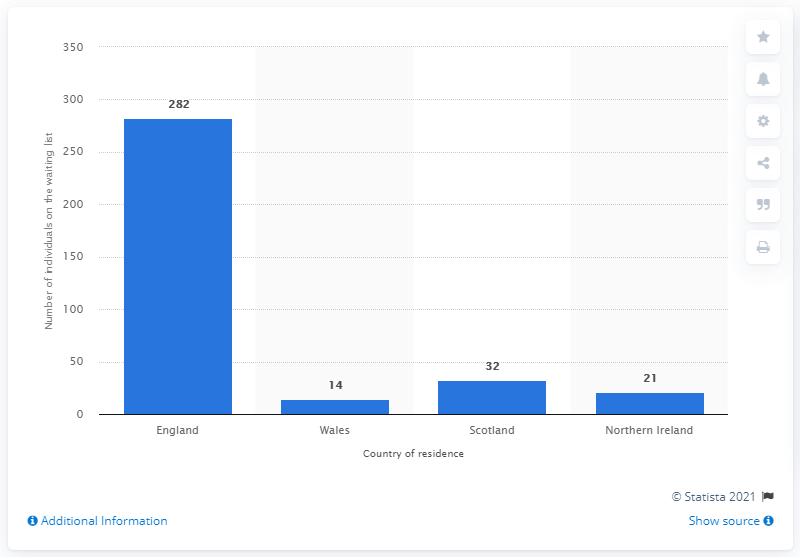Give some essential details in this illustration. As of the end of March 2020, there were 282 patients waiting for a lung transplant in England. 